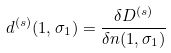<formula> <loc_0><loc_0><loc_500><loc_500>d ^ { ( s ) } ( 1 , \sigma _ { 1 } ) = \frac { \delta D ^ { ( s ) } } { \delta n ( 1 , \sigma _ { 1 } ) }</formula> 